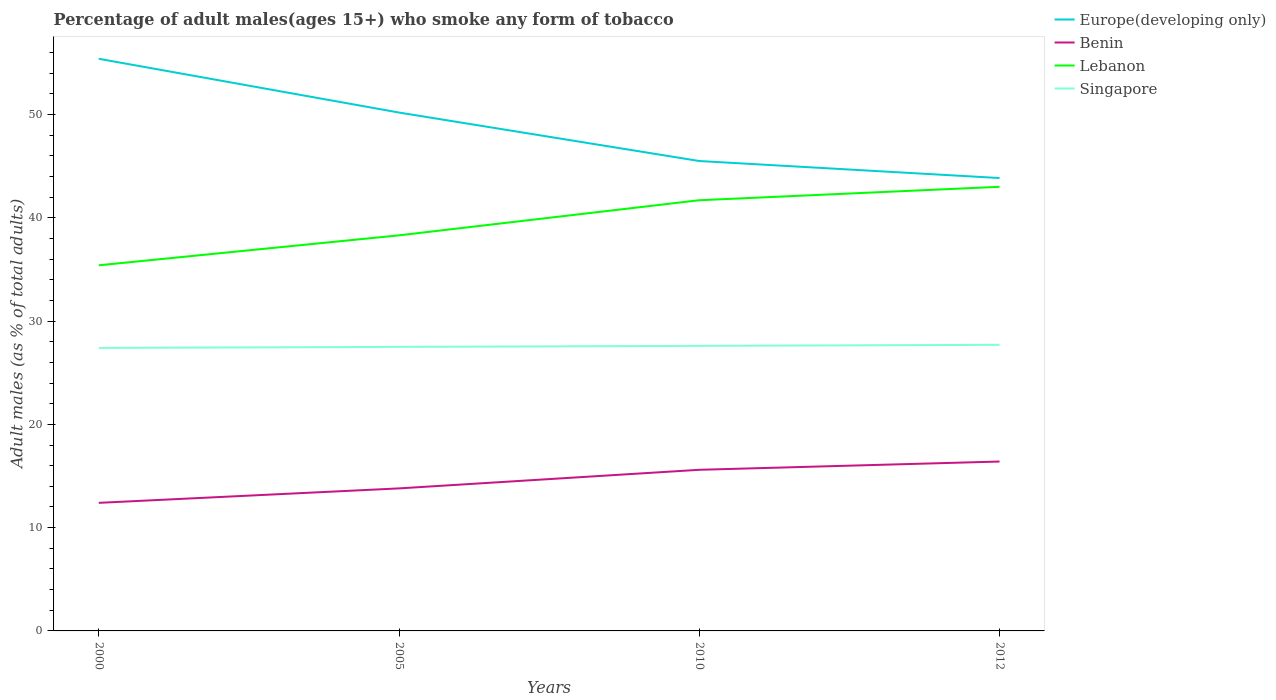How many different coloured lines are there?
Provide a short and direct response. 4. Across all years, what is the maximum percentage of adult males who smoke in Europe(developing only)?
Provide a short and direct response. 43.85. What is the total percentage of adult males who smoke in Benin in the graph?
Provide a short and direct response. -1.8. What is the difference between the highest and the second highest percentage of adult males who smoke in Lebanon?
Your answer should be very brief. 7.6. How many lines are there?
Provide a succinct answer. 4. What is the difference between two consecutive major ticks on the Y-axis?
Offer a terse response. 10. Does the graph contain any zero values?
Your response must be concise. No. Does the graph contain grids?
Give a very brief answer. No. How many legend labels are there?
Ensure brevity in your answer.  4. What is the title of the graph?
Your response must be concise. Percentage of adult males(ages 15+) who smoke any form of tobacco. Does "Guam" appear as one of the legend labels in the graph?
Give a very brief answer. No. What is the label or title of the Y-axis?
Your response must be concise. Adult males (as % of total adults). What is the Adult males (as % of total adults) of Europe(developing only) in 2000?
Your response must be concise. 55.4. What is the Adult males (as % of total adults) in Lebanon in 2000?
Your answer should be compact. 35.4. What is the Adult males (as % of total adults) in Singapore in 2000?
Ensure brevity in your answer.  27.4. What is the Adult males (as % of total adults) of Europe(developing only) in 2005?
Keep it short and to the point. 50.19. What is the Adult males (as % of total adults) of Benin in 2005?
Your response must be concise. 13.8. What is the Adult males (as % of total adults) in Lebanon in 2005?
Offer a very short reply. 38.3. What is the Adult males (as % of total adults) in Singapore in 2005?
Offer a very short reply. 27.5. What is the Adult males (as % of total adults) in Europe(developing only) in 2010?
Offer a very short reply. 45.5. What is the Adult males (as % of total adults) of Lebanon in 2010?
Ensure brevity in your answer.  41.7. What is the Adult males (as % of total adults) in Singapore in 2010?
Give a very brief answer. 27.6. What is the Adult males (as % of total adults) of Europe(developing only) in 2012?
Ensure brevity in your answer.  43.85. What is the Adult males (as % of total adults) in Benin in 2012?
Give a very brief answer. 16.4. What is the Adult males (as % of total adults) of Lebanon in 2012?
Ensure brevity in your answer.  43. What is the Adult males (as % of total adults) of Singapore in 2012?
Offer a terse response. 27.7. Across all years, what is the maximum Adult males (as % of total adults) of Europe(developing only)?
Make the answer very short. 55.4. Across all years, what is the maximum Adult males (as % of total adults) of Lebanon?
Offer a terse response. 43. Across all years, what is the maximum Adult males (as % of total adults) in Singapore?
Ensure brevity in your answer.  27.7. Across all years, what is the minimum Adult males (as % of total adults) of Europe(developing only)?
Your answer should be very brief. 43.85. Across all years, what is the minimum Adult males (as % of total adults) of Benin?
Give a very brief answer. 12.4. Across all years, what is the minimum Adult males (as % of total adults) in Lebanon?
Your answer should be very brief. 35.4. Across all years, what is the minimum Adult males (as % of total adults) in Singapore?
Ensure brevity in your answer.  27.4. What is the total Adult males (as % of total adults) of Europe(developing only) in the graph?
Offer a very short reply. 194.93. What is the total Adult males (as % of total adults) of Benin in the graph?
Your answer should be compact. 58.2. What is the total Adult males (as % of total adults) in Lebanon in the graph?
Provide a succinct answer. 158.4. What is the total Adult males (as % of total adults) in Singapore in the graph?
Keep it short and to the point. 110.2. What is the difference between the Adult males (as % of total adults) of Europe(developing only) in 2000 and that in 2005?
Make the answer very short. 5.21. What is the difference between the Adult males (as % of total adults) in Benin in 2000 and that in 2005?
Your response must be concise. -1.4. What is the difference between the Adult males (as % of total adults) in Singapore in 2000 and that in 2005?
Offer a terse response. -0.1. What is the difference between the Adult males (as % of total adults) of Europe(developing only) in 2000 and that in 2010?
Your answer should be very brief. 9.9. What is the difference between the Adult males (as % of total adults) of Europe(developing only) in 2000 and that in 2012?
Make the answer very short. 11.55. What is the difference between the Adult males (as % of total adults) in Lebanon in 2000 and that in 2012?
Provide a short and direct response. -7.6. What is the difference between the Adult males (as % of total adults) in Singapore in 2000 and that in 2012?
Offer a terse response. -0.3. What is the difference between the Adult males (as % of total adults) in Europe(developing only) in 2005 and that in 2010?
Your response must be concise. 4.69. What is the difference between the Adult males (as % of total adults) of Benin in 2005 and that in 2010?
Your response must be concise. -1.8. What is the difference between the Adult males (as % of total adults) in Europe(developing only) in 2005 and that in 2012?
Your answer should be very brief. 6.34. What is the difference between the Adult males (as % of total adults) in Singapore in 2005 and that in 2012?
Keep it short and to the point. -0.2. What is the difference between the Adult males (as % of total adults) of Europe(developing only) in 2010 and that in 2012?
Ensure brevity in your answer.  1.65. What is the difference between the Adult males (as % of total adults) in Lebanon in 2010 and that in 2012?
Offer a terse response. -1.3. What is the difference between the Adult males (as % of total adults) in Singapore in 2010 and that in 2012?
Offer a terse response. -0.1. What is the difference between the Adult males (as % of total adults) of Europe(developing only) in 2000 and the Adult males (as % of total adults) of Benin in 2005?
Your answer should be compact. 41.6. What is the difference between the Adult males (as % of total adults) of Europe(developing only) in 2000 and the Adult males (as % of total adults) of Lebanon in 2005?
Offer a terse response. 17.1. What is the difference between the Adult males (as % of total adults) of Europe(developing only) in 2000 and the Adult males (as % of total adults) of Singapore in 2005?
Offer a very short reply. 27.9. What is the difference between the Adult males (as % of total adults) of Benin in 2000 and the Adult males (as % of total adults) of Lebanon in 2005?
Provide a short and direct response. -25.9. What is the difference between the Adult males (as % of total adults) in Benin in 2000 and the Adult males (as % of total adults) in Singapore in 2005?
Give a very brief answer. -15.1. What is the difference between the Adult males (as % of total adults) in Lebanon in 2000 and the Adult males (as % of total adults) in Singapore in 2005?
Make the answer very short. 7.9. What is the difference between the Adult males (as % of total adults) in Europe(developing only) in 2000 and the Adult males (as % of total adults) in Benin in 2010?
Offer a terse response. 39.8. What is the difference between the Adult males (as % of total adults) of Europe(developing only) in 2000 and the Adult males (as % of total adults) of Lebanon in 2010?
Ensure brevity in your answer.  13.7. What is the difference between the Adult males (as % of total adults) of Europe(developing only) in 2000 and the Adult males (as % of total adults) of Singapore in 2010?
Provide a succinct answer. 27.8. What is the difference between the Adult males (as % of total adults) in Benin in 2000 and the Adult males (as % of total adults) in Lebanon in 2010?
Make the answer very short. -29.3. What is the difference between the Adult males (as % of total adults) of Benin in 2000 and the Adult males (as % of total adults) of Singapore in 2010?
Ensure brevity in your answer.  -15.2. What is the difference between the Adult males (as % of total adults) in Europe(developing only) in 2000 and the Adult males (as % of total adults) in Benin in 2012?
Your response must be concise. 39. What is the difference between the Adult males (as % of total adults) of Europe(developing only) in 2000 and the Adult males (as % of total adults) of Lebanon in 2012?
Provide a short and direct response. 12.4. What is the difference between the Adult males (as % of total adults) in Europe(developing only) in 2000 and the Adult males (as % of total adults) in Singapore in 2012?
Give a very brief answer. 27.7. What is the difference between the Adult males (as % of total adults) of Benin in 2000 and the Adult males (as % of total adults) of Lebanon in 2012?
Ensure brevity in your answer.  -30.6. What is the difference between the Adult males (as % of total adults) of Benin in 2000 and the Adult males (as % of total adults) of Singapore in 2012?
Your response must be concise. -15.3. What is the difference between the Adult males (as % of total adults) in Lebanon in 2000 and the Adult males (as % of total adults) in Singapore in 2012?
Provide a short and direct response. 7.7. What is the difference between the Adult males (as % of total adults) of Europe(developing only) in 2005 and the Adult males (as % of total adults) of Benin in 2010?
Offer a terse response. 34.59. What is the difference between the Adult males (as % of total adults) in Europe(developing only) in 2005 and the Adult males (as % of total adults) in Lebanon in 2010?
Provide a short and direct response. 8.49. What is the difference between the Adult males (as % of total adults) in Europe(developing only) in 2005 and the Adult males (as % of total adults) in Singapore in 2010?
Your answer should be very brief. 22.59. What is the difference between the Adult males (as % of total adults) in Benin in 2005 and the Adult males (as % of total adults) in Lebanon in 2010?
Make the answer very short. -27.9. What is the difference between the Adult males (as % of total adults) in Lebanon in 2005 and the Adult males (as % of total adults) in Singapore in 2010?
Provide a succinct answer. 10.7. What is the difference between the Adult males (as % of total adults) in Europe(developing only) in 2005 and the Adult males (as % of total adults) in Benin in 2012?
Offer a terse response. 33.79. What is the difference between the Adult males (as % of total adults) in Europe(developing only) in 2005 and the Adult males (as % of total adults) in Lebanon in 2012?
Your answer should be very brief. 7.19. What is the difference between the Adult males (as % of total adults) of Europe(developing only) in 2005 and the Adult males (as % of total adults) of Singapore in 2012?
Ensure brevity in your answer.  22.49. What is the difference between the Adult males (as % of total adults) in Benin in 2005 and the Adult males (as % of total adults) in Lebanon in 2012?
Your answer should be very brief. -29.2. What is the difference between the Adult males (as % of total adults) in Benin in 2005 and the Adult males (as % of total adults) in Singapore in 2012?
Offer a very short reply. -13.9. What is the difference between the Adult males (as % of total adults) in Lebanon in 2005 and the Adult males (as % of total adults) in Singapore in 2012?
Offer a very short reply. 10.6. What is the difference between the Adult males (as % of total adults) of Europe(developing only) in 2010 and the Adult males (as % of total adults) of Benin in 2012?
Give a very brief answer. 29.1. What is the difference between the Adult males (as % of total adults) of Europe(developing only) in 2010 and the Adult males (as % of total adults) of Lebanon in 2012?
Your answer should be very brief. 2.5. What is the difference between the Adult males (as % of total adults) of Europe(developing only) in 2010 and the Adult males (as % of total adults) of Singapore in 2012?
Your answer should be very brief. 17.8. What is the difference between the Adult males (as % of total adults) of Benin in 2010 and the Adult males (as % of total adults) of Lebanon in 2012?
Provide a succinct answer. -27.4. What is the difference between the Adult males (as % of total adults) in Benin in 2010 and the Adult males (as % of total adults) in Singapore in 2012?
Your answer should be very brief. -12.1. What is the difference between the Adult males (as % of total adults) of Lebanon in 2010 and the Adult males (as % of total adults) of Singapore in 2012?
Make the answer very short. 14. What is the average Adult males (as % of total adults) of Europe(developing only) per year?
Your response must be concise. 48.73. What is the average Adult males (as % of total adults) in Benin per year?
Ensure brevity in your answer.  14.55. What is the average Adult males (as % of total adults) of Lebanon per year?
Your answer should be compact. 39.6. What is the average Adult males (as % of total adults) of Singapore per year?
Your response must be concise. 27.55. In the year 2000, what is the difference between the Adult males (as % of total adults) in Europe(developing only) and Adult males (as % of total adults) in Benin?
Your answer should be compact. 43. In the year 2000, what is the difference between the Adult males (as % of total adults) of Europe(developing only) and Adult males (as % of total adults) of Lebanon?
Offer a terse response. 20. In the year 2000, what is the difference between the Adult males (as % of total adults) of Europe(developing only) and Adult males (as % of total adults) of Singapore?
Ensure brevity in your answer.  28. In the year 2000, what is the difference between the Adult males (as % of total adults) of Benin and Adult males (as % of total adults) of Singapore?
Provide a short and direct response. -15. In the year 2000, what is the difference between the Adult males (as % of total adults) of Lebanon and Adult males (as % of total adults) of Singapore?
Make the answer very short. 8. In the year 2005, what is the difference between the Adult males (as % of total adults) of Europe(developing only) and Adult males (as % of total adults) of Benin?
Ensure brevity in your answer.  36.39. In the year 2005, what is the difference between the Adult males (as % of total adults) of Europe(developing only) and Adult males (as % of total adults) of Lebanon?
Give a very brief answer. 11.89. In the year 2005, what is the difference between the Adult males (as % of total adults) of Europe(developing only) and Adult males (as % of total adults) of Singapore?
Provide a short and direct response. 22.69. In the year 2005, what is the difference between the Adult males (as % of total adults) in Benin and Adult males (as % of total adults) in Lebanon?
Offer a very short reply. -24.5. In the year 2005, what is the difference between the Adult males (as % of total adults) of Benin and Adult males (as % of total adults) of Singapore?
Ensure brevity in your answer.  -13.7. In the year 2010, what is the difference between the Adult males (as % of total adults) of Europe(developing only) and Adult males (as % of total adults) of Benin?
Your answer should be compact. 29.9. In the year 2010, what is the difference between the Adult males (as % of total adults) in Europe(developing only) and Adult males (as % of total adults) in Lebanon?
Your answer should be compact. 3.8. In the year 2010, what is the difference between the Adult males (as % of total adults) in Europe(developing only) and Adult males (as % of total adults) in Singapore?
Your answer should be very brief. 17.9. In the year 2010, what is the difference between the Adult males (as % of total adults) in Benin and Adult males (as % of total adults) in Lebanon?
Provide a short and direct response. -26.1. In the year 2010, what is the difference between the Adult males (as % of total adults) in Benin and Adult males (as % of total adults) in Singapore?
Give a very brief answer. -12. In the year 2010, what is the difference between the Adult males (as % of total adults) of Lebanon and Adult males (as % of total adults) of Singapore?
Your answer should be very brief. 14.1. In the year 2012, what is the difference between the Adult males (as % of total adults) of Europe(developing only) and Adult males (as % of total adults) of Benin?
Keep it short and to the point. 27.45. In the year 2012, what is the difference between the Adult males (as % of total adults) of Europe(developing only) and Adult males (as % of total adults) of Lebanon?
Ensure brevity in your answer.  0.85. In the year 2012, what is the difference between the Adult males (as % of total adults) of Europe(developing only) and Adult males (as % of total adults) of Singapore?
Make the answer very short. 16.15. In the year 2012, what is the difference between the Adult males (as % of total adults) in Benin and Adult males (as % of total adults) in Lebanon?
Your answer should be compact. -26.6. In the year 2012, what is the difference between the Adult males (as % of total adults) in Benin and Adult males (as % of total adults) in Singapore?
Your answer should be very brief. -11.3. In the year 2012, what is the difference between the Adult males (as % of total adults) in Lebanon and Adult males (as % of total adults) in Singapore?
Make the answer very short. 15.3. What is the ratio of the Adult males (as % of total adults) of Europe(developing only) in 2000 to that in 2005?
Your response must be concise. 1.1. What is the ratio of the Adult males (as % of total adults) of Benin in 2000 to that in 2005?
Your response must be concise. 0.9. What is the ratio of the Adult males (as % of total adults) in Lebanon in 2000 to that in 2005?
Your answer should be very brief. 0.92. What is the ratio of the Adult males (as % of total adults) of Europe(developing only) in 2000 to that in 2010?
Provide a succinct answer. 1.22. What is the ratio of the Adult males (as % of total adults) in Benin in 2000 to that in 2010?
Provide a succinct answer. 0.79. What is the ratio of the Adult males (as % of total adults) of Lebanon in 2000 to that in 2010?
Your answer should be very brief. 0.85. What is the ratio of the Adult males (as % of total adults) in Europe(developing only) in 2000 to that in 2012?
Give a very brief answer. 1.26. What is the ratio of the Adult males (as % of total adults) in Benin in 2000 to that in 2012?
Ensure brevity in your answer.  0.76. What is the ratio of the Adult males (as % of total adults) in Lebanon in 2000 to that in 2012?
Provide a succinct answer. 0.82. What is the ratio of the Adult males (as % of total adults) in Singapore in 2000 to that in 2012?
Your answer should be very brief. 0.99. What is the ratio of the Adult males (as % of total adults) of Europe(developing only) in 2005 to that in 2010?
Your answer should be compact. 1.1. What is the ratio of the Adult males (as % of total adults) in Benin in 2005 to that in 2010?
Offer a very short reply. 0.88. What is the ratio of the Adult males (as % of total adults) in Lebanon in 2005 to that in 2010?
Give a very brief answer. 0.92. What is the ratio of the Adult males (as % of total adults) of Singapore in 2005 to that in 2010?
Ensure brevity in your answer.  1. What is the ratio of the Adult males (as % of total adults) of Europe(developing only) in 2005 to that in 2012?
Your answer should be very brief. 1.14. What is the ratio of the Adult males (as % of total adults) in Benin in 2005 to that in 2012?
Provide a short and direct response. 0.84. What is the ratio of the Adult males (as % of total adults) of Lebanon in 2005 to that in 2012?
Offer a terse response. 0.89. What is the ratio of the Adult males (as % of total adults) in Europe(developing only) in 2010 to that in 2012?
Your answer should be very brief. 1.04. What is the ratio of the Adult males (as % of total adults) of Benin in 2010 to that in 2012?
Provide a short and direct response. 0.95. What is the ratio of the Adult males (as % of total adults) in Lebanon in 2010 to that in 2012?
Keep it short and to the point. 0.97. What is the difference between the highest and the second highest Adult males (as % of total adults) in Europe(developing only)?
Ensure brevity in your answer.  5.21. What is the difference between the highest and the second highest Adult males (as % of total adults) in Benin?
Offer a terse response. 0.8. What is the difference between the highest and the second highest Adult males (as % of total adults) of Lebanon?
Your answer should be compact. 1.3. What is the difference between the highest and the second highest Adult males (as % of total adults) of Singapore?
Keep it short and to the point. 0.1. What is the difference between the highest and the lowest Adult males (as % of total adults) in Europe(developing only)?
Your answer should be very brief. 11.55. 